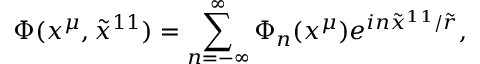Convert formula to latex. <formula><loc_0><loc_0><loc_500><loc_500>\Phi ( x ^ { \mu } , { \tilde { x } } ^ { 1 1 } ) = \sum _ { n = - \infty } ^ { \infty } \Phi _ { n } ( x ^ { \mu } ) e ^ { i n { \tilde { x } } ^ { 1 1 } / { \tilde { r } } } ,</formula> 